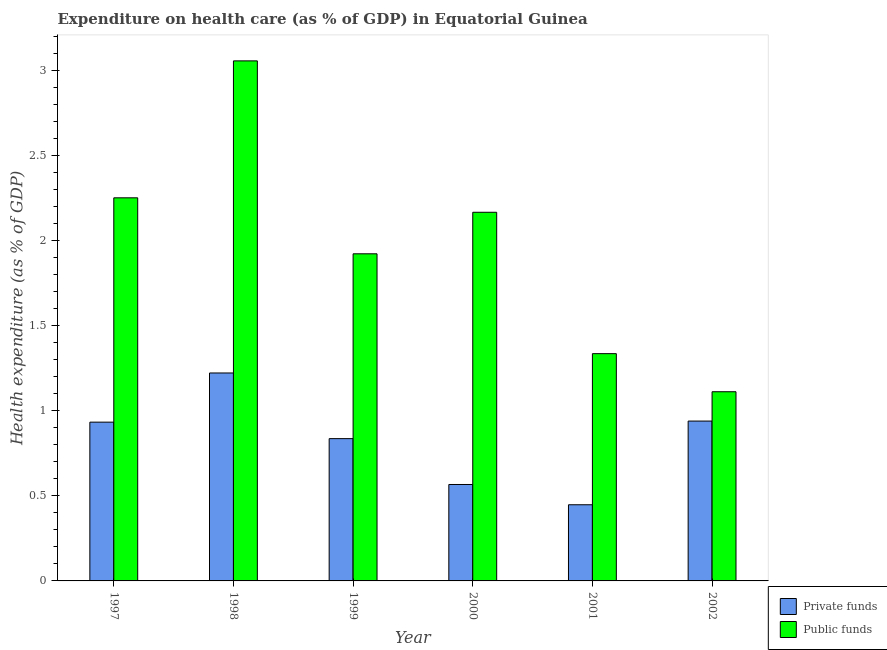How many different coloured bars are there?
Provide a short and direct response. 2. Are the number of bars on each tick of the X-axis equal?
Offer a very short reply. Yes. How many bars are there on the 2nd tick from the left?
Provide a short and direct response. 2. How many bars are there on the 3rd tick from the right?
Ensure brevity in your answer.  2. In how many cases, is the number of bars for a given year not equal to the number of legend labels?
Ensure brevity in your answer.  0. What is the amount of private funds spent in healthcare in 1998?
Offer a terse response. 1.22. Across all years, what is the maximum amount of private funds spent in healthcare?
Your answer should be compact. 1.22. Across all years, what is the minimum amount of public funds spent in healthcare?
Offer a very short reply. 1.11. What is the total amount of private funds spent in healthcare in the graph?
Make the answer very short. 4.94. What is the difference between the amount of public funds spent in healthcare in 1998 and that in 2000?
Your response must be concise. 0.89. What is the difference between the amount of private funds spent in healthcare in 2000 and the amount of public funds spent in healthcare in 1999?
Your response must be concise. -0.27. What is the average amount of private funds spent in healthcare per year?
Make the answer very short. 0.82. In the year 1999, what is the difference between the amount of public funds spent in healthcare and amount of private funds spent in healthcare?
Provide a succinct answer. 0. What is the ratio of the amount of private funds spent in healthcare in 2000 to that in 2001?
Offer a very short reply. 1.27. Is the difference between the amount of private funds spent in healthcare in 1997 and 2000 greater than the difference between the amount of public funds spent in healthcare in 1997 and 2000?
Keep it short and to the point. No. What is the difference between the highest and the second highest amount of private funds spent in healthcare?
Provide a succinct answer. 0.28. What is the difference between the highest and the lowest amount of public funds spent in healthcare?
Ensure brevity in your answer.  1.94. In how many years, is the amount of private funds spent in healthcare greater than the average amount of private funds spent in healthcare taken over all years?
Offer a very short reply. 4. Is the sum of the amount of private funds spent in healthcare in 1999 and 2000 greater than the maximum amount of public funds spent in healthcare across all years?
Your answer should be compact. Yes. What does the 2nd bar from the left in 1999 represents?
Keep it short and to the point. Public funds. What does the 1st bar from the right in 2000 represents?
Give a very brief answer. Public funds. Are all the bars in the graph horizontal?
Keep it short and to the point. No. Does the graph contain grids?
Provide a short and direct response. No. Where does the legend appear in the graph?
Offer a terse response. Bottom right. How are the legend labels stacked?
Offer a very short reply. Vertical. What is the title of the graph?
Provide a short and direct response. Expenditure on health care (as % of GDP) in Equatorial Guinea. Does "Foreign liabilities" appear as one of the legend labels in the graph?
Keep it short and to the point. No. What is the label or title of the Y-axis?
Make the answer very short. Health expenditure (as % of GDP). What is the Health expenditure (as % of GDP) of Private funds in 1997?
Your response must be concise. 0.93. What is the Health expenditure (as % of GDP) of Public funds in 1997?
Offer a very short reply. 2.25. What is the Health expenditure (as % of GDP) of Private funds in 1998?
Offer a terse response. 1.22. What is the Health expenditure (as % of GDP) in Public funds in 1998?
Your answer should be very brief. 3.06. What is the Health expenditure (as % of GDP) in Private funds in 1999?
Ensure brevity in your answer.  0.84. What is the Health expenditure (as % of GDP) in Public funds in 1999?
Keep it short and to the point. 1.92. What is the Health expenditure (as % of GDP) in Private funds in 2000?
Offer a very short reply. 0.57. What is the Health expenditure (as % of GDP) in Public funds in 2000?
Make the answer very short. 2.17. What is the Health expenditure (as % of GDP) in Private funds in 2001?
Make the answer very short. 0.45. What is the Health expenditure (as % of GDP) in Public funds in 2001?
Provide a succinct answer. 1.34. What is the Health expenditure (as % of GDP) in Private funds in 2002?
Offer a very short reply. 0.94. What is the Health expenditure (as % of GDP) of Public funds in 2002?
Ensure brevity in your answer.  1.11. Across all years, what is the maximum Health expenditure (as % of GDP) in Private funds?
Give a very brief answer. 1.22. Across all years, what is the maximum Health expenditure (as % of GDP) in Public funds?
Give a very brief answer. 3.06. Across all years, what is the minimum Health expenditure (as % of GDP) of Private funds?
Make the answer very short. 0.45. Across all years, what is the minimum Health expenditure (as % of GDP) in Public funds?
Your response must be concise. 1.11. What is the total Health expenditure (as % of GDP) in Private funds in the graph?
Offer a very short reply. 4.94. What is the total Health expenditure (as % of GDP) of Public funds in the graph?
Make the answer very short. 11.84. What is the difference between the Health expenditure (as % of GDP) of Private funds in 1997 and that in 1998?
Make the answer very short. -0.29. What is the difference between the Health expenditure (as % of GDP) of Public funds in 1997 and that in 1998?
Provide a short and direct response. -0.8. What is the difference between the Health expenditure (as % of GDP) in Private funds in 1997 and that in 1999?
Provide a short and direct response. 0.1. What is the difference between the Health expenditure (as % of GDP) in Public funds in 1997 and that in 1999?
Make the answer very short. 0.33. What is the difference between the Health expenditure (as % of GDP) of Private funds in 1997 and that in 2000?
Your answer should be very brief. 0.37. What is the difference between the Health expenditure (as % of GDP) of Public funds in 1997 and that in 2000?
Make the answer very short. 0.09. What is the difference between the Health expenditure (as % of GDP) of Private funds in 1997 and that in 2001?
Keep it short and to the point. 0.49. What is the difference between the Health expenditure (as % of GDP) of Public funds in 1997 and that in 2001?
Your answer should be very brief. 0.92. What is the difference between the Health expenditure (as % of GDP) in Private funds in 1997 and that in 2002?
Give a very brief answer. -0.01. What is the difference between the Health expenditure (as % of GDP) of Public funds in 1997 and that in 2002?
Your answer should be compact. 1.14. What is the difference between the Health expenditure (as % of GDP) in Private funds in 1998 and that in 1999?
Ensure brevity in your answer.  0.39. What is the difference between the Health expenditure (as % of GDP) of Public funds in 1998 and that in 1999?
Ensure brevity in your answer.  1.13. What is the difference between the Health expenditure (as % of GDP) of Private funds in 1998 and that in 2000?
Keep it short and to the point. 0.66. What is the difference between the Health expenditure (as % of GDP) of Public funds in 1998 and that in 2000?
Offer a terse response. 0.89. What is the difference between the Health expenditure (as % of GDP) of Private funds in 1998 and that in 2001?
Give a very brief answer. 0.77. What is the difference between the Health expenditure (as % of GDP) in Public funds in 1998 and that in 2001?
Give a very brief answer. 1.72. What is the difference between the Health expenditure (as % of GDP) in Private funds in 1998 and that in 2002?
Provide a succinct answer. 0.28. What is the difference between the Health expenditure (as % of GDP) in Public funds in 1998 and that in 2002?
Your answer should be very brief. 1.94. What is the difference between the Health expenditure (as % of GDP) of Private funds in 1999 and that in 2000?
Offer a very short reply. 0.27. What is the difference between the Health expenditure (as % of GDP) of Public funds in 1999 and that in 2000?
Provide a short and direct response. -0.24. What is the difference between the Health expenditure (as % of GDP) of Private funds in 1999 and that in 2001?
Provide a succinct answer. 0.39. What is the difference between the Health expenditure (as % of GDP) in Public funds in 1999 and that in 2001?
Make the answer very short. 0.59. What is the difference between the Health expenditure (as % of GDP) of Private funds in 1999 and that in 2002?
Provide a succinct answer. -0.1. What is the difference between the Health expenditure (as % of GDP) in Public funds in 1999 and that in 2002?
Your answer should be very brief. 0.81. What is the difference between the Health expenditure (as % of GDP) in Private funds in 2000 and that in 2001?
Offer a very short reply. 0.12. What is the difference between the Health expenditure (as % of GDP) of Public funds in 2000 and that in 2001?
Your answer should be very brief. 0.83. What is the difference between the Health expenditure (as % of GDP) of Private funds in 2000 and that in 2002?
Keep it short and to the point. -0.37. What is the difference between the Health expenditure (as % of GDP) in Public funds in 2000 and that in 2002?
Your response must be concise. 1.05. What is the difference between the Health expenditure (as % of GDP) of Private funds in 2001 and that in 2002?
Make the answer very short. -0.49. What is the difference between the Health expenditure (as % of GDP) of Public funds in 2001 and that in 2002?
Make the answer very short. 0.22. What is the difference between the Health expenditure (as % of GDP) of Private funds in 1997 and the Health expenditure (as % of GDP) of Public funds in 1998?
Provide a succinct answer. -2.12. What is the difference between the Health expenditure (as % of GDP) of Private funds in 1997 and the Health expenditure (as % of GDP) of Public funds in 1999?
Give a very brief answer. -0.99. What is the difference between the Health expenditure (as % of GDP) of Private funds in 1997 and the Health expenditure (as % of GDP) of Public funds in 2000?
Keep it short and to the point. -1.23. What is the difference between the Health expenditure (as % of GDP) of Private funds in 1997 and the Health expenditure (as % of GDP) of Public funds in 2001?
Provide a succinct answer. -0.4. What is the difference between the Health expenditure (as % of GDP) of Private funds in 1997 and the Health expenditure (as % of GDP) of Public funds in 2002?
Make the answer very short. -0.18. What is the difference between the Health expenditure (as % of GDP) of Private funds in 1998 and the Health expenditure (as % of GDP) of Public funds in 1999?
Provide a succinct answer. -0.7. What is the difference between the Health expenditure (as % of GDP) of Private funds in 1998 and the Health expenditure (as % of GDP) of Public funds in 2000?
Your answer should be compact. -0.94. What is the difference between the Health expenditure (as % of GDP) of Private funds in 1998 and the Health expenditure (as % of GDP) of Public funds in 2001?
Provide a short and direct response. -0.11. What is the difference between the Health expenditure (as % of GDP) in Private funds in 1998 and the Health expenditure (as % of GDP) in Public funds in 2002?
Ensure brevity in your answer.  0.11. What is the difference between the Health expenditure (as % of GDP) in Private funds in 1999 and the Health expenditure (as % of GDP) in Public funds in 2000?
Your answer should be compact. -1.33. What is the difference between the Health expenditure (as % of GDP) in Private funds in 1999 and the Health expenditure (as % of GDP) in Public funds in 2001?
Your answer should be very brief. -0.5. What is the difference between the Health expenditure (as % of GDP) of Private funds in 1999 and the Health expenditure (as % of GDP) of Public funds in 2002?
Give a very brief answer. -0.28. What is the difference between the Health expenditure (as % of GDP) of Private funds in 2000 and the Health expenditure (as % of GDP) of Public funds in 2001?
Offer a very short reply. -0.77. What is the difference between the Health expenditure (as % of GDP) in Private funds in 2000 and the Health expenditure (as % of GDP) in Public funds in 2002?
Your answer should be compact. -0.55. What is the difference between the Health expenditure (as % of GDP) in Private funds in 2001 and the Health expenditure (as % of GDP) in Public funds in 2002?
Offer a terse response. -0.66. What is the average Health expenditure (as % of GDP) in Private funds per year?
Give a very brief answer. 0.82. What is the average Health expenditure (as % of GDP) of Public funds per year?
Provide a short and direct response. 1.97. In the year 1997, what is the difference between the Health expenditure (as % of GDP) of Private funds and Health expenditure (as % of GDP) of Public funds?
Your answer should be very brief. -1.32. In the year 1998, what is the difference between the Health expenditure (as % of GDP) in Private funds and Health expenditure (as % of GDP) in Public funds?
Your answer should be very brief. -1.83. In the year 1999, what is the difference between the Health expenditure (as % of GDP) in Private funds and Health expenditure (as % of GDP) in Public funds?
Provide a succinct answer. -1.09. In the year 2000, what is the difference between the Health expenditure (as % of GDP) of Private funds and Health expenditure (as % of GDP) of Public funds?
Provide a succinct answer. -1.6. In the year 2001, what is the difference between the Health expenditure (as % of GDP) of Private funds and Health expenditure (as % of GDP) of Public funds?
Your answer should be very brief. -0.89. In the year 2002, what is the difference between the Health expenditure (as % of GDP) of Private funds and Health expenditure (as % of GDP) of Public funds?
Make the answer very short. -0.17. What is the ratio of the Health expenditure (as % of GDP) in Private funds in 1997 to that in 1998?
Provide a succinct answer. 0.76. What is the ratio of the Health expenditure (as % of GDP) of Public funds in 1997 to that in 1998?
Offer a terse response. 0.74. What is the ratio of the Health expenditure (as % of GDP) of Private funds in 1997 to that in 1999?
Offer a terse response. 1.12. What is the ratio of the Health expenditure (as % of GDP) of Public funds in 1997 to that in 1999?
Your answer should be compact. 1.17. What is the ratio of the Health expenditure (as % of GDP) of Private funds in 1997 to that in 2000?
Give a very brief answer. 1.65. What is the ratio of the Health expenditure (as % of GDP) in Public funds in 1997 to that in 2000?
Provide a succinct answer. 1.04. What is the ratio of the Health expenditure (as % of GDP) of Private funds in 1997 to that in 2001?
Your answer should be compact. 2.08. What is the ratio of the Health expenditure (as % of GDP) in Public funds in 1997 to that in 2001?
Offer a terse response. 1.69. What is the ratio of the Health expenditure (as % of GDP) of Public funds in 1997 to that in 2002?
Offer a terse response. 2.02. What is the ratio of the Health expenditure (as % of GDP) in Private funds in 1998 to that in 1999?
Keep it short and to the point. 1.46. What is the ratio of the Health expenditure (as % of GDP) in Public funds in 1998 to that in 1999?
Give a very brief answer. 1.59. What is the ratio of the Health expenditure (as % of GDP) of Private funds in 1998 to that in 2000?
Your answer should be very brief. 2.16. What is the ratio of the Health expenditure (as % of GDP) in Public funds in 1998 to that in 2000?
Keep it short and to the point. 1.41. What is the ratio of the Health expenditure (as % of GDP) in Private funds in 1998 to that in 2001?
Offer a very short reply. 2.73. What is the ratio of the Health expenditure (as % of GDP) of Public funds in 1998 to that in 2001?
Offer a very short reply. 2.29. What is the ratio of the Health expenditure (as % of GDP) of Private funds in 1998 to that in 2002?
Keep it short and to the point. 1.3. What is the ratio of the Health expenditure (as % of GDP) in Public funds in 1998 to that in 2002?
Your answer should be very brief. 2.75. What is the ratio of the Health expenditure (as % of GDP) of Private funds in 1999 to that in 2000?
Keep it short and to the point. 1.48. What is the ratio of the Health expenditure (as % of GDP) of Public funds in 1999 to that in 2000?
Your answer should be very brief. 0.89. What is the ratio of the Health expenditure (as % of GDP) in Private funds in 1999 to that in 2001?
Your answer should be very brief. 1.87. What is the ratio of the Health expenditure (as % of GDP) of Public funds in 1999 to that in 2001?
Make the answer very short. 1.44. What is the ratio of the Health expenditure (as % of GDP) of Private funds in 1999 to that in 2002?
Your response must be concise. 0.89. What is the ratio of the Health expenditure (as % of GDP) of Public funds in 1999 to that in 2002?
Provide a succinct answer. 1.73. What is the ratio of the Health expenditure (as % of GDP) of Private funds in 2000 to that in 2001?
Your answer should be very brief. 1.27. What is the ratio of the Health expenditure (as % of GDP) of Public funds in 2000 to that in 2001?
Ensure brevity in your answer.  1.62. What is the ratio of the Health expenditure (as % of GDP) in Private funds in 2000 to that in 2002?
Give a very brief answer. 0.6. What is the ratio of the Health expenditure (as % of GDP) in Public funds in 2000 to that in 2002?
Your answer should be compact. 1.95. What is the ratio of the Health expenditure (as % of GDP) in Private funds in 2001 to that in 2002?
Give a very brief answer. 0.48. What is the ratio of the Health expenditure (as % of GDP) in Public funds in 2001 to that in 2002?
Your answer should be compact. 1.2. What is the difference between the highest and the second highest Health expenditure (as % of GDP) in Private funds?
Make the answer very short. 0.28. What is the difference between the highest and the second highest Health expenditure (as % of GDP) of Public funds?
Your answer should be compact. 0.8. What is the difference between the highest and the lowest Health expenditure (as % of GDP) of Private funds?
Provide a succinct answer. 0.77. What is the difference between the highest and the lowest Health expenditure (as % of GDP) of Public funds?
Offer a very short reply. 1.94. 